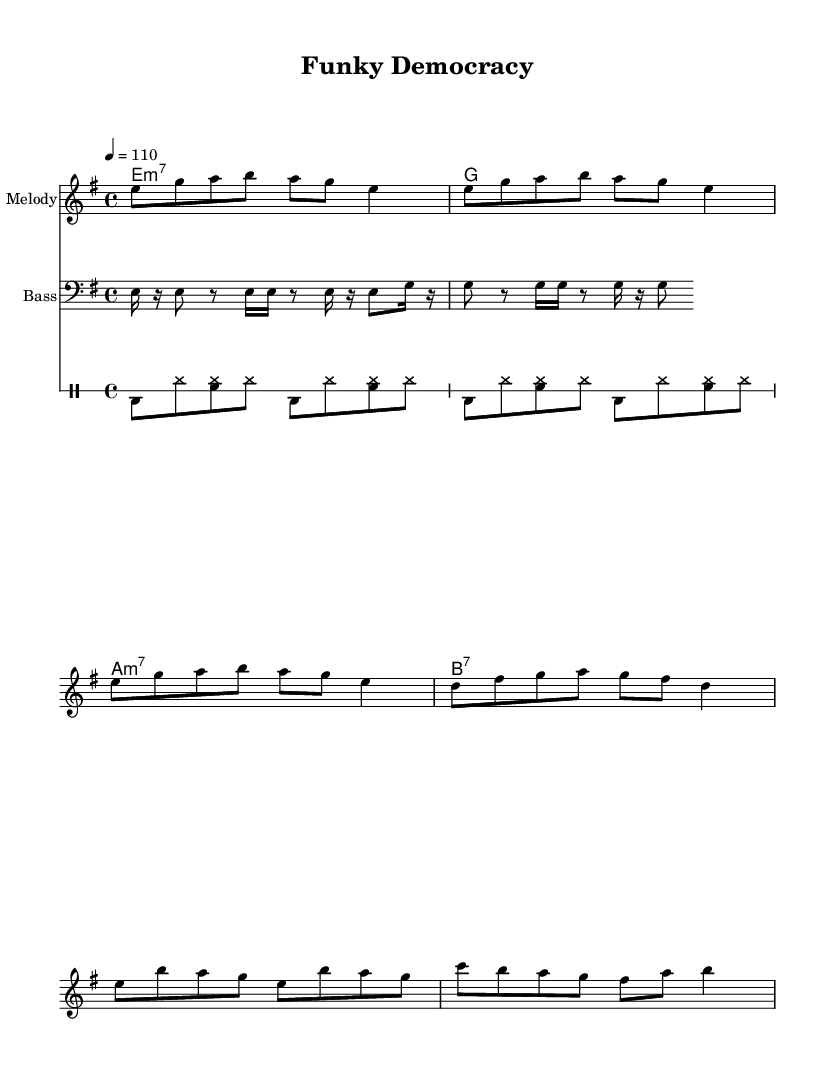What is the key signature of this music? The key signature is indicated by the presence of one sharp, which signifies that it is E minor. The key signature appears right after the clef and before the time signature.
Answer: E minor What is the time signature of this music? The time signature is shown as a fraction at the beginning of the music, visually presented as 4 over 4. This means four beats in each measure.
Answer: 4/4 What is the tempo marking in this sheet music? The tempo is specified in beats per minute, indicated at the start. Here, it reads "4 = 110," meaning there are 110 beats per minute.
Answer: 110 How many measures does the melody section contain? To determine this, we look at the four-bar groups in the melody, consisting of eight measures presented in the notation. By counting each individual measure grouped visually, we find there are eight.
Answer: 8 What type of seventh chord is used in the harmonies? The harmonies include a minor seventh chord, specifically an E minor 7, indicated by the "m7" notation following the root note. Each chord listed also follows a specific voicing that fits typical Funk arrangements.
Answer: E minor 7 What musical genre does this composition represent? The composition contains syncopated rhythms, a strong bass line, and a lively groove characteristic of Funk music, making it easily identifiable as such. The title "Funky Democracy" also hints at the genre.
Answer: Funk Which instrument is likely to play the syncopated rhythm indicated in the drum staff? The drum staff is designed for the drum set, which usually includes bass drum, snare drum, and hi-hat. The notation shown indicates a tight, syncopated groove typical for a drummer.
Answer: Drum set 